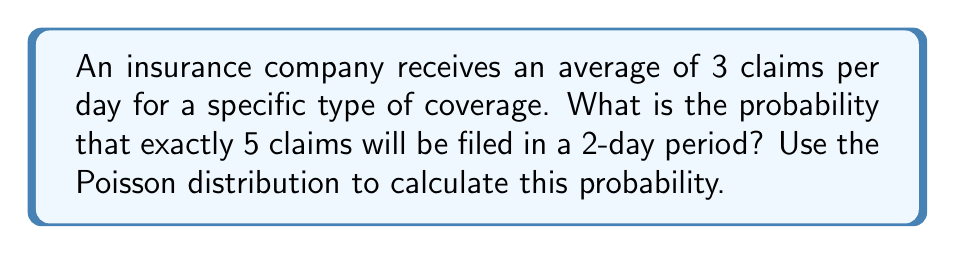Show me your answer to this math problem. To solve this problem, we'll use the Poisson distribution formula:

$$P(X = k) = \frac{e^{-\lambda} \lambda^k}{k!}$$

Where:
$\lambda$ = average number of events in the given time period
$k$ = number of events we're calculating the probability for
$e$ = Euler's number (approximately 2.71828)

Step 1: Calculate $\lambda$ for a 2-day period
$\lambda = 3$ claims/day × 2 days = 6 claims

Step 2: Set up the Poisson formula with $k = 5$ and $\lambda = 6$
$$P(X = 5) = \frac{e^{-6} 6^5}{5!}$$

Step 3: Calculate the numerator
$e^{-6} \approx 0.00247875$
$6^5 = 7776$
$e^{-6} 6^5 \approx 19.2739$

Step 4: Calculate the denominator
$5! = 5 \times 4 \times 3 \times 2 \times 1 = 120$

Step 5: Divide the numerator by the denominator
$$P(X = 5) = \frac{19.2739}{120} \approx 0.1606$$

Therefore, the probability of exactly 5 claims being filed in a 2-day period is approximately 0.1606 or 16.06%.
Answer: 0.1606 